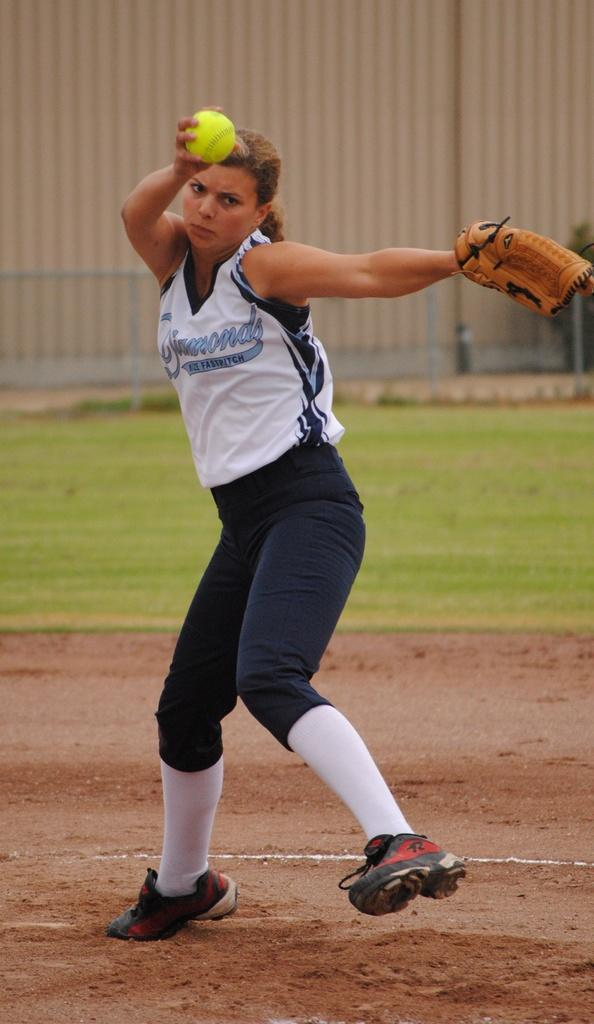<image>
Describe the image concisely. the softball player has a top saying Diamond Fastpitch 